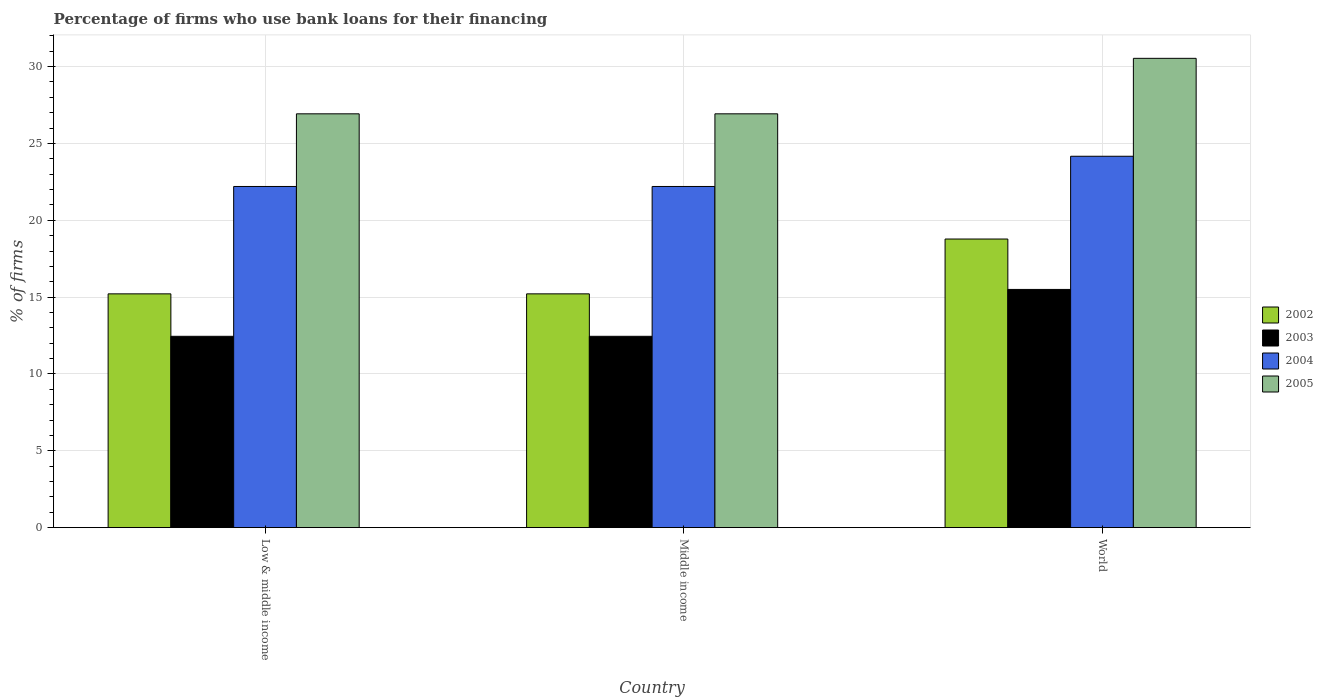How many groups of bars are there?
Provide a short and direct response. 3. Are the number of bars per tick equal to the number of legend labels?
Provide a short and direct response. Yes. How many bars are there on the 1st tick from the left?
Make the answer very short. 4. What is the percentage of firms who use bank loans for their financing in 2003 in Low & middle income?
Provide a succinct answer. 12.45. In which country was the percentage of firms who use bank loans for their financing in 2002 minimum?
Provide a short and direct response. Low & middle income. What is the total percentage of firms who use bank loans for their financing in 2005 in the graph?
Give a very brief answer. 84.39. What is the difference between the percentage of firms who use bank loans for their financing in 2005 in Low & middle income and the percentage of firms who use bank loans for their financing in 2003 in World?
Your answer should be compact. 11.43. What is the average percentage of firms who use bank loans for their financing in 2002 per country?
Offer a very short reply. 16.4. What is the difference between the percentage of firms who use bank loans for their financing of/in 2002 and percentage of firms who use bank loans for their financing of/in 2005 in World?
Provide a short and direct response. -11.76. In how many countries, is the percentage of firms who use bank loans for their financing in 2004 greater than 16 %?
Keep it short and to the point. 3. What is the ratio of the percentage of firms who use bank loans for their financing in 2005 in Middle income to that in World?
Your answer should be compact. 0.88. Is the percentage of firms who use bank loans for their financing in 2005 in Low & middle income less than that in Middle income?
Your answer should be very brief. No. Is the difference between the percentage of firms who use bank loans for their financing in 2002 in Low & middle income and Middle income greater than the difference between the percentage of firms who use bank loans for their financing in 2005 in Low & middle income and Middle income?
Your response must be concise. No. What is the difference between the highest and the second highest percentage of firms who use bank loans for their financing in 2003?
Provide a succinct answer. -3.05. What is the difference between the highest and the lowest percentage of firms who use bank loans for their financing in 2004?
Ensure brevity in your answer.  1.97. In how many countries, is the percentage of firms who use bank loans for their financing in 2004 greater than the average percentage of firms who use bank loans for their financing in 2004 taken over all countries?
Provide a short and direct response. 1. Is the sum of the percentage of firms who use bank loans for their financing in 2002 in Low & middle income and Middle income greater than the maximum percentage of firms who use bank loans for their financing in 2004 across all countries?
Offer a very short reply. Yes. Is it the case that in every country, the sum of the percentage of firms who use bank loans for their financing in 2005 and percentage of firms who use bank loans for their financing in 2004 is greater than the percentage of firms who use bank loans for their financing in 2003?
Ensure brevity in your answer.  Yes. How many bars are there?
Your answer should be compact. 12. Are all the bars in the graph horizontal?
Offer a very short reply. No. How many countries are there in the graph?
Keep it short and to the point. 3. Does the graph contain any zero values?
Provide a succinct answer. No. Does the graph contain grids?
Offer a very short reply. Yes. How many legend labels are there?
Keep it short and to the point. 4. What is the title of the graph?
Your answer should be very brief. Percentage of firms who use bank loans for their financing. Does "1977" appear as one of the legend labels in the graph?
Offer a very short reply. No. What is the label or title of the Y-axis?
Your response must be concise. % of firms. What is the % of firms of 2002 in Low & middle income?
Your response must be concise. 15.21. What is the % of firms of 2003 in Low & middle income?
Your answer should be compact. 12.45. What is the % of firms of 2004 in Low & middle income?
Ensure brevity in your answer.  22.2. What is the % of firms of 2005 in Low & middle income?
Offer a very short reply. 26.93. What is the % of firms in 2002 in Middle income?
Offer a very short reply. 15.21. What is the % of firms in 2003 in Middle income?
Provide a short and direct response. 12.45. What is the % of firms in 2004 in Middle income?
Provide a short and direct response. 22.2. What is the % of firms of 2005 in Middle income?
Provide a short and direct response. 26.93. What is the % of firms in 2002 in World?
Keep it short and to the point. 18.78. What is the % of firms of 2003 in World?
Provide a succinct answer. 15.5. What is the % of firms of 2004 in World?
Offer a terse response. 24.17. What is the % of firms of 2005 in World?
Provide a succinct answer. 30.54. Across all countries, what is the maximum % of firms of 2002?
Provide a succinct answer. 18.78. Across all countries, what is the maximum % of firms of 2003?
Give a very brief answer. 15.5. Across all countries, what is the maximum % of firms of 2004?
Your response must be concise. 24.17. Across all countries, what is the maximum % of firms of 2005?
Offer a terse response. 30.54. Across all countries, what is the minimum % of firms of 2002?
Provide a short and direct response. 15.21. Across all countries, what is the minimum % of firms of 2003?
Provide a short and direct response. 12.45. Across all countries, what is the minimum % of firms of 2004?
Your answer should be very brief. 22.2. Across all countries, what is the minimum % of firms of 2005?
Give a very brief answer. 26.93. What is the total % of firms in 2002 in the graph?
Provide a short and direct response. 49.21. What is the total % of firms of 2003 in the graph?
Offer a terse response. 40.4. What is the total % of firms in 2004 in the graph?
Your answer should be very brief. 68.57. What is the total % of firms in 2005 in the graph?
Your response must be concise. 84.39. What is the difference between the % of firms in 2003 in Low & middle income and that in Middle income?
Ensure brevity in your answer.  0. What is the difference between the % of firms of 2002 in Low & middle income and that in World?
Your response must be concise. -3.57. What is the difference between the % of firms of 2003 in Low & middle income and that in World?
Make the answer very short. -3.05. What is the difference between the % of firms in 2004 in Low & middle income and that in World?
Provide a short and direct response. -1.97. What is the difference between the % of firms in 2005 in Low & middle income and that in World?
Ensure brevity in your answer.  -3.61. What is the difference between the % of firms in 2002 in Middle income and that in World?
Your answer should be very brief. -3.57. What is the difference between the % of firms in 2003 in Middle income and that in World?
Your response must be concise. -3.05. What is the difference between the % of firms of 2004 in Middle income and that in World?
Make the answer very short. -1.97. What is the difference between the % of firms in 2005 in Middle income and that in World?
Your response must be concise. -3.61. What is the difference between the % of firms of 2002 in Low & middle income and the % of firms of 2003 in Middle income?
Ensure brevity in your answer.  2.76. What is the difference between the % of firms in 2002 in Low & middle income and the % of firms in 2004 in Middle income?
Make the answer very short. -6.99. What is the difference between the % of firms of 2002 in Low & middle income and the % of firms of 2005 in Middle income?
Ensure brevity in your answer.  -11.72. What is the difference between the % of firms in 2003 in Low & middle income and the % of firms in 2004 in Middle income?
Give a very brief answer. -9.75. What is the difference between the % of firms in 2003 in Low & middle income and the % of firms in 2005 in Middle income?
Your answer should be compact. -14.48. What is the difference between the % of firms of 2004 in Low & middle income and the % of firms of 2005 in Middle income?
Offer a terse response. -4.73. What is the difference between the % of firms of 2002 in Low & middle income and the % of firms of 2003 in World?
Ensure brevity in your answer.  -0.29. What is the difference between the % of firms in 2002 in Low & middle income and the % of firms in 2004 in World?
Make the answer very short. -8.95. What is the difference between the % of firms of 2002 in Low & middle income and the % of firms of 2005 in World?
Keep it short and to the point. -15.33. What is the difference between the % of firms in 2003 in Low & middle income and the % of firms in 2004 in World?
Offer a terse response. -11.72. What is the difference between the % of firms of 2003 in Low & middle income and the % of firms of 2005 in World?
Your response must be concise. -18.09. What is the difference between the % of firms of 2004 in Low & middle income and the % of firms of 2005 in World?
Your response must be concise. -8.34. What is the difference between the % of firms of 2002 in Middle income and the % of firms of 2003 in World?
Ensure brevity in your answer.  -0.29. What is the difference between the % of firms in 2002 in Middle income and the % of firms in 2004 in World?
Provide a short and direct response. -8.95. What is the difference between the % of firms in 2002 in Middle income and the % of firms in 2005 in World?
Provide a short and direct response. -15.33. What is the difference between the % of firms in 2003 in Middle income and the % of firms in 2004 in World?
Your response must be concise. -11.72. What is the difference between the % of firms in 2003 in Middle income and the % of firms in 2005 in World?
Offer a terse response. -18.09. What is the difference between the % of firms in 2004 in Middle income and the % of firms in 2005 in World?
Your answer should be compact. -8.34. What is the average % of firms in 2002 per country?
Offer a terse response. 16.4. What is the average % of firms in 2003 per country?
Your answer should be compact. 13.47. What is the average % of firms of 2004 per country?
Your response must be concise. 22.86. What is the average % of firms of 2005 per country?
Your answer should be very brief. 28.13. What is the difference between the % of firms in 2002 and % of firms in 2003 in Low & middle income?
Ensure brevity in your answer.  2.76. What is the difference between the % of firms of 2002 and % of firms of 2004 in Low & middle income?
Keep it short and to the point. -6.99. What is the difference between the % of firms in 2002 and % of firms in 2005 in Low & middle income?
Offer a very short reply. -11.72. What is the difference between the % of firms of 2003 and % of firms of 2004 in Low & middle income?
Keep it short and to the point. -9.75. What is the difference between the % of firms of 2003 and % of firms of 2005 in Low & middle income?
Give a very brief answer. -14.48. What is the difference between the % of firms in 2004 and % of firms in 2005 in Low & middle income?
Your response must be concise. -4.73. What is the difference between the % of firms in 2002 and % of firms in 2003 in Middle income?
Your response must be concise. 2.76. What is the difference between the % of firms in 2002 and % of firms in 2004 in Middle income?
Offer a very short reply. -6.99. What is the difference between the % of firms of 2002 and % of firms of 2005 in Middle income?
Offer a terse response. -11.72. What is the difference between the % of firms of 2003 and % of firms of 2004 in Middle income?
Provide a short and direct response. -9.75. What is the difference between the % of firms of 2003 and % of firms of 2005 in Middle income?
Your answer should be compact. -14.48. What is the difference between the % of firms in 2004 and % of firms in 2005 in Middle income?
Offer a terse response. -4.73. What is the difference between the % of firms in 2002 and % of firms in 2003 in World?
Offer a very short reply. 3.28. What is the difference between the % of firms in 2002 and % of firms in 2004 in World?
Ensure brevity in your answer.  -5.39. What is the difference between the % of firms of 2002 and % of firms of 2005 in World?
Offer a terse response. -11.76. What is the difference between the % of firms of 2003 and % of firms of 2004 in World?
Provide a succinct answer. -8.67. What is the difference between the % of firms in 2003 and % of firms in 2005 in World?
Offer a very short reply. -15.04. What is the difference between the % of firms of 2004 and % of firms of 2005 in World?
Provide a short and direct response. -6.37. What is the ratio of the % of firms in 2002 in Low & middle income to that in Middle income?
Provide a short and direct response. 1. What is the ratio of the % of firms of 2003 in Low & middle income to that in Middle income?
Offer a very short reply. 1. What is the ratio of the % of firms in 2005 in Low & middle income to that in Middle income?
Provide a succinct answer. 1. What is the ratio of the % of firms in 2002 in Low & middle income to that in World?
Your answer should be very brief. 0.81. What is the ratio of the % of firms of 2003 in Low & middle income to that in World?
Give a very brief answer. 0.8. What is the ratio of the % of firms of 2004 in Low & middle income to that in World?
Make the answer very short. 0.92. What is the ratio of the % of firms in 2005 in Low & middle income to that in World?
Provide a succinct answer. 0.88. What is the ratio of the % of firms of 2002 in Middle income to that in World?
Keep it short and to the point. 0.81. What is the ratio of the % of firms of 2003 in Middle income to that in World?
Provide a short and direct response. 0.8. What is the ratio of the % of firms in 2004 in Middle income to that in World?
Provide a succinct answer. 0.92. What is the ratio of the % of firms of 2005 in Middle income to that in World?
Offer a terse response. 0.88. What is the difference between the highest and the second highest % of firms of 2002?
Keep it short and to the point. 3.57. What is the difference between the highest and the second highest % of firms in 2003?
Offer a very short reply. 3.05. What is the difference between the highest and the second highest % of firms in 2004?
Give a very brief answer. 1.97. What is the difference between the highest and the second highest % of firms of 2005?
Keep it short and to the point. 3.61. What is the difference between the highest and the lowest % of firms in 2002?
Provide a short and direct response. 3.57. What is the difference between the highest and the lowest % of firms of 2003?
Provide a short and direct response. 3.05. What is the difference between the highest and the lowest % of firms in 2004?
Ensure brevity in your answer.  1.97. What is the difference between the highest and the lowest % of firms of 2005?
Give a very brief answer. 3.61. 